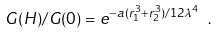<formula> <loc_0><loc_0><loc_500><loc_500>G ( H ) / G ( 0 ) = e ^ { - a ( r _ { 1 } ^ { 3 } + r _ { 2 } ^ { 3 } ) / 1 2 \lambda ^ { 4 } } \ .</formula> 